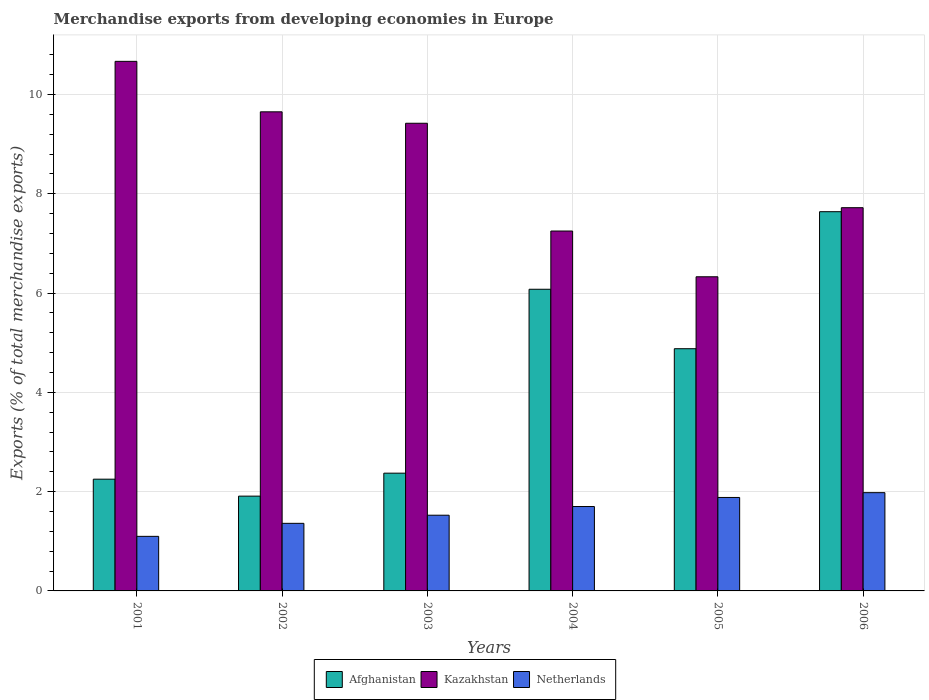How many different coloured bars are there?
Your response must be concise. 3. How many groups of bars are there?
Ensure brevity in your answer.  6. Are the number of bars per tick equal to the number of legend labels?
Provide a short and direct response. Yes. Are the number of bars on each tick of the X-axis equal?
Ensure brevity in your answer.  Yes. How many bars are there on the 1st tick from the left?
Give a very brief answer. 3. How many bars are there on the 3rd tick from the right?
Your answer should be very brief. 3. What is the label of the 2nd group of bars from the left?
Provide a succinct answer. 2002. What is the percentage of total merchandise exports in Kazakhstan in 2003?
Your response must be concise. 9.42. Across all years, what is the maximum percentage of total merchandise exports in Afghanistan?
Provide a succinct answer. 7.64. Across all years, what is the minimum percentage of total merchandise exports in Netherlands?
Offer a very short reply. 1.1. In which year was the percentage of total merchandise exports in Netherlands minimum?
Provide a succinct answer. 2001. What is the total percentage of total merchandise exports in Netherlands in the graph?
Your answer should be compact. 9.55. What is the difference between the percentage of total merchandise exports in Kazakhstan in 2004 and that in 2005?
Ensure brevity in your answer.  0.92. What is the difference between the percentage of total merchandise exports in Kazakhstan in 2001 and the percentage of total merchandise exports in Afghanistan in 2006?
Keep it short and to the point. 3.03. What is the average percentage of total merchandise exports in Netherlands per year?
Give a very brief answer. 1.59. In the year 2004, what is the difference between the percentage of total merchandise exports in Kazakhstan and percentage of total merchandise exports in Afghanistan?
Provide a succinct answer. 1.17. In how many years, is the percentage of total merchandise exports in Netherlands greater than 1.6 %?
Your answer should be very brief. 3. What is the ratio of the percentage of total merchandise exports in Netherlands in 2001 to that in 2006?
Provide a short and direct response. 0.56. What is the difference between the highest and the second highest percentage of total merchandise exports in Afghanistan?
Offer a very short reply. 1.56. What is the difference between the highest and the lowest percentage of total merchandise exports in Afghanistan?
Give a very brief answer. 5.73. Is the sum of the percentage of total merchandise exports in Kazakhstan in 2004 and 2006 greater than the maximum percentage of total merchandise exports in Afghanistan across all years?
Provide a succinct answer. Yes. What does the 2nd bar from the left in 2004 represents?
Give a very brief answer. Kazakhstan. What does the 2nd bar from the right in 2004 represents?
Ensure brevity in your answer.  Kazakhstan. Is it the case that in every year, the sum of the percentage of total merchandise exports in Kazakhstan and percentage of total merchandise exports in Netherlands is greater than the percentage of total merchandise exports in Afghanistan?
Your answer should be compact. Yes. Are all the bars in the graph horizontal?
Provide a short and direct response. No. How many years are there in the graph?
Ensure brevity in your answer.  6. Does the graph contain any zero values?
Ensure brevity in your answer.  No. Does the graph contain grids?
Offer a terse response. Yes. How many legend labels are there?
Offer a terse response. 3. How are the legend labels stacked?
Make the answer very short. Horizontal. What is the title of the graph?
Your answer should be compact. Merchandise exports from developing economies in Europe. What is the label or title of the Y-axis?
Give a very brief answer. Exports (% of total merchandise exports). What is the Exports (% of total merchandise exports) of Afghanistan in 2001?
Your answer should be compact. 2.25. What is the Exports (% of total merchandise exports) of Kazakhstan in 2001?
Ensure brevity in your answer.  10.67. What is the Exports (% of total merchandise exports) of Netherlands in 2001?
Offer a terse response. 1.1. What is the Exports (% of total merchandise exports) in Afghanistan in 2002?
Provide a short and direct response. 1.91. What is the Exports (% of total merchandise exports) in Kazakhstan in 2002?
Your answer should be compact. 9.65. What is the Exports (% of total merchandise exports) of Netherlands in 2002?
Your response must be concise. 1.36. What is the Exports (% of total merchandise exports) in Afghanistan in 2003?
Make the answer very short. 2.37. What is the Exports (% of total merchandise exports) in Kazakhstan in 2003?
Ensure brevity in your answer.  9.42. What is the Exports (% of total merchandise exports) in Netherlands in 2003?
Your response must be concise. 1.52. What is the Exports (% of total merchandise exports) of Afghanistan in 2004?
Ensure brevity in your answer.  6.08. What is the Exports (% of total merchandise exports) of Kazakhstan in 2004?
Your response must be concise. 7.25. What is the Exports (% of total merchandise exports) of Netherlands in 2004?
Your answer should be compact. 1.7. What is the Exports (% of total merchandise exports) of Afghanistan in 2005?
Provide a short and direct response. 4.88. What is the Exports (% of total merchandise exports) in Kazakhstan in 2005?
Make the answer very short. 6.33. What is the Exports (% of total merchandise exports) of Netherlands in 2005?
Make the answer very short. 1.88. What is the Exports (% of total merchandise exports) of Afghanistan in 2006?
Offer a terse response. 7.64. What is the Exports (% of total merchandise exports) in Kazakhstan in 2006?
Provide a succinct answer. 7.72. What is the Exports (% of total merchandise exports) in Netherlands in 2006?
Offer a very short reply. 1.98. Across all years, what is the maximum Exports (% of total merchandise exports) of Afghanistan?
Give a very brief answer. 7.64. Across all years, what is the maximum Exports (% of total merchandise exports) in Kazakhstan?
Ensure brevity in your answer.  10.67. Across all years, what is the maximum Exports (% of total merchandise exports) in Netherlands?
Your response must be concise. 1.98. Across all years, what is the minimum Exports (% of total merchandise exports) of Afghanistan?
Provide a succinct answer. 1.91. Across all years, what is the minimum Exports (% of total merchandise exports) in Kazakhstan?
Give a very brief answer. 6.33. Across all years, what is the minimum Exports (% of total merchandise exports) in Netherlands?
Ensure brevity in your answer.  1.1. What is the total Exports (% of total merchandise exports) in Afghanistan in the graph?
Ensure brevity in your answer.  25.12. What is the total Exports (% of total merchandise exports) in Kazakhstan in the graph?
Your answer should be very brief. 51.03. What is the total Exports (% of total merchandise exports) in Netherlands in the graph?
Provide a succinct answer. 9.55. What is the difference between the Exports (% of total merchandise exports) in Afghanistan in 2001 and that in 2002?
Keep it short and to the point. 0.34. What is the difference between the Exports (% of total merchandise exports) of Kazakhstan in 2001 and that in 2002?
Keep it short and to the point. 1.02. What is the difference between the Exports (% of total merchandise exports) of Netherlands in 2001 and that in 2002?
Make the answer very short. -0.26. What is the difference between the Exports (% of total merchandise exports) of Afghanistan in 2001 and that in 2003?
Offer a terse response. -0.12. What is the difference between the Exports (% of total merchandise exports) of Kazakhstan in 2001 and that in 2003?
Your answer should be compact. 1.25. What is the difference between the Exports (% of total merchandise exports) in Netherlands in 2001 and that in 2003?
Your response must be concise. -0.43. What is the difference between the Exports (% of total merchandise exports) in Afghanistan in 2001 and that in 2004?
Provide a succinct answer. -3.83. What is the difference between the Exports (% of total merchandise exports) of Kazakhstan in 2001 and that in 2004?
Your answer should be very brief. 3.42. What is the difference between the Exports (% of total merchandise exports) of Netherlands in 2001 and that in 2004?
Ensure brevity in your answer.  -0.6. What is the difference between the Exports (% of total merchandise exports) of Afghanistan in 2001 and that in 2005?
Give a very brief answer. -2.63. What is the difference between the Exports (% of total merchandise exports) in Kazakhstan in 2001 and that in 2005?
Provide a succinct answer. 4.34. What is the difference between the Exports (% of total merchandise exports) of Netherlands in 2001 and that in 2005?
Your answer should be very brief. -0.78. What is the difference between the Exports (% of total merchandise exports) in Afghanistan in 2001 and that in 2006?
Offer a terse response. -5.39. What is the difference between the Exports (% of total merchandise exports) of Kazakhstan in 2001 and that in 2006?
Give a very brief answer. 2.95. What is the difference between the Exports (% of total merchandise exports) in Netherlands in 2001 and that in 2006?
Make the answer very short. -0.88. What is the difference between the Exports (% of total merchandise exports) in Afghanistan in 2002 and that in 2003?
Provide a succinct answer. -0.46. What is the difference between the Exports (% of total merchandise exports) in Kazakhstan in 2002 and that in 2003?
Offer a terse response. 0.23. What is the difference between the Exports (% of total merchandise exports) in Netherlands in 2002 and that in 2003?
Offer a very short reply. -0.16. What is the difference between the Exports (% of total merchandise exports) in Afghanistan in 2002 and that in 2004?
Keep it short and to the point. -4.17. What is the difference between the Exports (% of total merchandise exports) of Kazakhstan in 2002 and that in 2004?
Your answer should be compact. 2.4. What is the difference between the Exports (% of total merchandise exports) in Netherlands in 2002 and that in 2004?
Make the answer very short. -0.34. What is the difference between the Exports (% of total merchandise exports) of Afghanistan in 2002 and that in 2005?
Provide a short and direct response. -2.97. What is the difference between the Exports (% of total merchandise exports) of Kazakhstan in 2002 and that in 2005?
Provide a short and direct response. 3.32. What is the difference between the Exports (% of total merchandise exports) in Netherlands in 2002 and that in 2005?
Provide a short and direct response. -0.52. What is the difference between the Exports (% of total merchandise exports) in Afghanistan in 2002 and that in 2006?
Provide a short and direct response. -5.73. What is the difference between the Exports (% of total merchandise exports) of Kazakhstan in 2002 and that in 2006?
Offer a very short reply. 1.93. What is the difference between the Exports (% of total merchandise exports) of Netherlands in 2002 and that in 2006?
Offer a very short reply. -0.62. What is the difference between the Exports (% of total merchandise exports) in Afghanistan in 2003 and that in 2004?
Your response must be concise. -3.7. What is the difference between the Exports (% of total merchandise exports) in Kazakhstan in 2003 and that in 2004?
Offer a terse response. 2.17. What is the difference between the Exports (% of total merchandise exports) in Netherlands in 2003 and that in 2004?
Provide a succinct answer. -0.18. What is the difference between the Exports (% of total merchandise exports) in Afghanistan in 2003 and that in 2005?
Your answer should be compact. -2.51. What is the difference between the Exports (% of total merchandise exports) in Kazakhstan in 2003 and that in 2005?
Ensure brevity in your answer.  3.09. What is the difference between the Exports (% of total merchandise exports) of Netherlands in 2003 and that in 2005?
Keep it short and to the point. -0.36. What is the difference between the Exports (% of total merchandise exports) in Afghanistan in 2003 and that in 2006?
Provide a succinct answer. -5.27. What is the difference between the Exports (% of total merchandise exports) of Kazakhstan in 2003 and that in 2006?
Offer a terse response. 1.7. What is the difference between the Exports (% of total merchandise exports) of Netherlands in 2003 and that in 2006?
Offer a very short reply. -0.45. What is the difference between the Exports (% of total merchandise exports) in Afghanistan in 2004 and that in 2005?
Make the answer very short. 1.2. What is the difference between the Exports (% of total merchandise exports) of Kazakhstan in 2004 and that in 2005?
Your answer should be very brief. 0.92. What is the difference between the Exports (% of total merchandise exports) of Netherlands in 2004 and that in 2005?
Provide a succinct answer. -0.18. What is the difference between the Exports (% of total merchandise exports) in Afghanistan in 2004 and that in 2006?
Provide a succinct answer. -1.56. What is the difference between the Exports (% of total merchandise exports) in Kazakhstan in 2004 and that in 2006?
Your answer should be very brief. -0.47. What is the difference between the Exports (% of total merchandise exports) of Netherlands in 2004 and that in 2006?
Ensure brevity in your answer.  -0.28. What is the difference between the Exports (% of total merchandise exports) of Afghanistan in 2005 and that in 2006?
Your response must be concise. -2.76. What is the difference between the Exports (% of total merchandise exports) of Kazakhstan in 2005 and that in 2006?
Your answer should be compact. -1.39. What is the difference between the Exports (% of total merchandise exports) of Netherlands in 2005 and that in 2006?
Offer a terse response. -0.1. What is the difference between the Exports (% of total merchandise exports) in Afghanistan in 2001 and the Exports (% of total merchandise exports) in Kazakhstan in 2002?
Make the answer very short. -7.4. What is the difference between the Exports (% of total merchandise exports) of Afghanistan in 2001 and the Exports (% of total merchandise exports) of Netherlands in 2002?
Provide a succinct answer. 0.89. What is the difference between the Exports (% of total merchandise exports) of Kazakhstan in 2001 and the Exports (% of total merchandise exports) of Netherlands in 2002?
Your answer should be very brief. 9.31. What is the difference between the Exports (% of total merchandise exports) in Afghanistan in 2001 and the Exports (% of total merchandise exports) in Kazakhstan in 2003?
Your answer should be compact. -7.17. What is the difference between the Exports (% of total merchandise exports) in Afghanistan in 2001 and the Exports (% of total merchandise exports) in Netherlands in 2003?
Give a very brief answer. 0.73. What is the difference between the Exports (% of total merchandise exports) of Kazakhstan in 2001 and the Exports (% of total merchandise exports) of Netherlands in 2003?
Your response must be concise. 9.14. What is the difference between the Exports (% of total merchandise exports) of Afghanistan in 2001 and the Exports (% of total merchandise exports) of Kazakhstan in 2004?
Your answer should be compact. -5. What is the difference between the Exports (% of total merchandise exports) in Afghanistan in 2001 and the Exports (% of total merchandise exports) in Netherlands in 2004?
Your response must be concise. 0.55. What is the difference between the Exports (% of total merchandise exports) of Kazakhstan in 2001 and the Exports (% of total merchandise exports) of Netherlands in 2004?
Provide a short and direct response. 8.97. What is the difference between the Exports (% of total merchandise exports) of Afghanistan in 2001 and the Exports (% of total merchandise exports) of Kazakhstan in 2005?
Offer a very short reply. -4.08. What is the difference between the Exports (% of total merchandise exports) of Afghanistan in 2001 and the Exports (% of total merchandise exports) of Netherlands in 2005?
Offer a very short reply. 0.37. What is the difference between the Exports (% of total merchandise exports) in Kazakhstan in 2001 and the Exports (% of total merchandise exports) in Netherlands in 2005?
Your answer should be compact. 8.78. What is the difference between the Exports (% of total merchandise exports) in Afghanistan in 2001 and the Exports (% of total merchandise exports) in Kazakhstan in 2006?
Your response must be concise. -5.47. What is the difference between the Exports (% of total merchandise exports) of Afghanistan in 2001 and the Exports (% of total merchandise exports) of Netherlands in 2006?
Ensure brevity in your answer.  0.27. What is the difference between the Exports (% of total merchandise exports) in Kazakhstan in 2001 and the Exports (% of total merchandise exports) in Netherlands in 2006?
Ensure brevity in your answer.  8.69. What is the difference between the Exports (% of total merchandise exports) of Afghanistan in 2002 and the Exports (% of total merchandise exports) of Kazakhstan in 2003?
Offer a very short reply. -7.51. What is the difference between the Exports (% of total merchandise exports) of Afghanistan in 2002 and the Exports (% of total merchandise exports) of Netherlands in 2003?
Ensure brevity in your answer.  0.38. What is the difference between the Exports (% of total merchandise exports) in Kazakhstan in 2002 and the Exports (% of total merchandise exports) in Netherlands in 2003?
Ensure brevity in your answer.  8.12. What is the difference between the Exports (% of total merchandise exports) in Afghanistan in 2002 and the Exports (% of total merchandise exports) in Kazakhstan in 2004?
Offer a terse response. -5.34. What is the difference between the Exports (% of total merchandise exports) of Afghanistan in 2002 and the Exports (% of total merchandise exports) of Netherlands in 2004?
Your response must be concise. 0.21. What is the difference between the Exports (% of total merchandise exports) in Kazakhstan in 2002 and the Exports (% of total merchandise exports) in Netherlands in 2004?
Your response must be concise. 7.95. What is the difference between the Exports (% of total merchandise exports) in Afghanistan in 2002 and the Exports (% of total merchandise exports) in Kazakhstan in 2005?
Your answer should be very brief. -4.42. What is the difference between the Exports (% of total merchandise exports) of Afghanistan in 2002 and the Exports (% of total merchandise exports) of Netherlands in 2005?
Your response must be concise. 0.03. What is the difference between the Exports (% of total merchandise exports) of Kazakhstan in 2002 and the Exports (% of total merchandise exports) of Netherlands in 2005?
Offer a very short reply. 7.77. What is the difference between the Exports (% of total merchandise exports) in Afghanistan in 2002 and the Exports (% of total merchandise exports) in Kazakhstan in 2006?
Your response must be concise. -5.81. What is the difference between the Exports (% of total merchandise exports) of Afghanistan in 2002 and the Exports (% of total merchandise exports) of Netherlands in 2006?
Keep it short and to the point. -0.07. What is the difference between the Exports (% of total merchandise exports) of Kazakhstan in 2002 and the Exports (% of total merchandise exports) of Netherlands in 2006?
Offer a very short reply. 7.67. What is the difference between the Exports (% of total merchandise exports) of Afghanistan in 2003 and the Exports (% of total merchandise exports) of Kazakhstan in 2004?
Provide a short and direct response. -4.88. What is the difference between the Exports (% of total merchandise exports) in Afghanistan in 2003 and the Exports (% of total merchandise exports) in Netherlands in 2004?
Your answer should be very brief. 0.67. What is the difference between the Exports (% of total merchandise exports) of Kazakhstan in 2003 and the Exports (% of total merchandise exports) of Netherlands in 2004?
Offer a very short reply. 7.72. What is the difference between the Exports (% of total merchandise exports) of Afghanistan in 2003 and the Exports (% of total merchandise exports) of Kazakhstan in 2005?
Your answer should be compact. -3.96. What is the difference between the Exports (% of total merchandise exports) of Afghanistan in 2003 and the Exports (% of total merchandise exports) of Netherlands in 2005?
Provide a succinct answer. 0.49. What is the difference between the Exports (% of total merchandise exports) in Kazakhstan in 2003 and the Exports (% of total merchandise exports) in Netherlands in 2005?
Your answer should be very brief. 7.54. What is the difference between the Exports (% of total merchandise exports) in Afghanistan in 2003 and the Exports (% of total merchandise exports) in Kazakhstan in 2006?
Keep it short and to the point. -5.35. What is the difference between the Exports (% of total merchandise exports) of Afghanistan in 2003 and the Exports (% of total merchandise exports) of Netherlands in 2006?
Your response must be concise. 0.39. What is the difference between the Exports (% of total merchandise exports) of Kazakhstan in 2003 and the Exports (% of total merchandise exports) of Netherlands in 2006?
Your answer should be compact. 7.44. What is the difference between the Exports (% of total merchandise exports) in Afghanistan in 2004 and the Exports (% of total merchandise exports) in Kazakhstan in 2005?
Ensure brevity in your answer.  -0.25. What is the difference between the Exports (% of total merchandise exports) of Afghanistan in 2004 and the Exports (% of total merchandise exports) of Netherlands in 2005?
Give a very brief answer. 4.19. What is the difference between the Exports (% of total merchandise exports) in Kazakhstan in 2004 and the Exports (% of total merchandise exports) in Netherlands in 2005?
Offer a terse response. 5.37. What is the difference between the Exports (% of total merchandise exports) of Afghanistan in 2004 and the Exports (% of total merchandise exports) of Kazakhstan in 2006?
Your answer should be very brief. -1.64. What is the difference between the Exports (% of total merchandise exports) of Afghanistan in 2004 and the Exports (% of total merchandise exports) of Netherlands in 2006?
Offer a very short reply. 4.1. What is the difference between the Exports (% of total merchandise exports) of Kazakhstan in 2004 and the Exports (% of total merchandise exports) of Netherlands in 2006?
Offer a very short reply. 5.27. What is the difference between the Exports (% of total merchandise exports) in Afghanistan in 2005 and the Exports (% of total merchandise exports) in Kazakhstan in 2006?
Provide a succinct answer. -2.84. What is the difference between the Exports (% of total merchandise exports) in Afghanistan in 2005 and the Exports (% of total merchandise exports) in Netherlands in 2006?
Ensure brevity in your answer.  2.9. What is the difference between the Exports (% of total merchandise exports) in Kazakhstan in 2005 and the Exports (% of total merchandise exports) in Netherlands in 2006?
Offer a terse response. 4.35. What is the average Exports (% of total merchandise exports) in Afghanistan per year?
Offer a very short reply. 4.19. What is the average Exports (% of total merchandise exports) of Kazakhstan per year?
Provide a succinct answer. 8.51. What is the average Exports (% of total merchandise exports) of Netherlands per year?
Provide a short and direct response. 1.59. In the year 2001, what is the difference between the Exports (% of total merchandise exports) of Afghanistan and Exports (% of total merchandise exports) of Kazakhstan?
Offer a terse response. -8.42. In the year 2001, what is the difference between the Exports (% of total merchandise exports) of Afghanistan and Exports (% of total merchandise exports) of Netherlands?
Give a very brief answer. 1.15. In the year 2001, what is the difference between the Exports (% of total merchandise exports) in Kazakhstan and Exports (% of total merchandise exports) in Netherlands?
Provide a short and direct response. 9.57. In the year 2002, what is the difference between the Exports (% of total merchandise exports) in Afghanistan and Exports (% of total merchandise exports) in Kazakhstan?
Give a very brief answer. -7.74. In the year 2002, what is the difference between the Exports (% of total merchandise exports) in Afghanistan and Exports (% of total merchandise exports) in Netherlands?
Your response must be concise. 0.55. In the year 2002, what is the difference between the Exports (% of total merchandise exports) of Kazakhstan and Exports (% of total merchandise exports) of Netherlands?
Offer a terse response. 8.29. In the year 2003, what is the difference between the Exports (% of total merchandise exports) in Afghanistan and Exports (% of total merchandise exports) in Kazakhstan?
Ensure brevity in your answer.  -7.05. In the year 2003, what is the difference between the Exports (% of total merchandise exports) of Afghanistan and Exports (% of total merchandise exports) of Netherlands?
Offer a very short reply. 0.85. In the year 2003, what is the difference between the Exports (% of total merchandise exports) of Kazakhstan and Exports (% of total merchandise exports) of Netherlands?
Offer a terse response. 7.89. In the year 2004, what is the difference between the Exports (% of total merchandise exports) in Afghanistan and Exports (% of total merchandise exports) in Kazakhstan?
Ensure brevity in your answer.  -1.17. In the year 2004, what is the difference between the Exports (% of total merchandise exports) of Afghanistan and Exports (% of total merchandise exports) of Netherlands?
Your answer should be compact. 4.38. In the year 2004, what is the difference between the Exports (% of total merchandise exports) in Kazakhstan and Exports (% of total merchandise exports) in Netherlands?
Give a very brief answer. 5.55. In the year 2005, what is the difference between the Exports (% of total merchandise exports) in Afghanistan and Exports (% of total merchandise exports) in Kazakhstan?
Your answer should be compact. -1.45. In the year 2005, what is the difference between the Exports (% of total merchandise exports) of Afghanistan and Exports (% of total merchandise exports) of Netherlands?
Your answer should be compact. 3. In the year 2005, what is the difference between the Exports (% of total merchandise exports) of Kazakhstan and Exports (% of total merchandise exports) of Netherlands?
Make the answer very short. 4.45. In the year 2006, what is the difference between the Exports (% of total merchandise exports) in Afghanistan and Exports (% of total merchandise exports) in Kazakhstan?
Keep it short and to the point. -0.08. In the year 2006, what is the difference between the Exports (% of total merchandise exports) in Afghanistan and Exports (% of total merchandise exports) in Netherlands?
Offer a terse response. 5.66. In the year 2006, what is the difference between the Exports (% of total merchandise exports) of Kazakhstan and Exports (% of total merchandise exports) of Netherlands?
Your response must be concise. 5.74. What is the ratio of the Exports (% of total merchandise exports) in Afghanistan in 2001 to that in 2002?
Your answer should be compact. 1.18. What is the ratio of the Exports (% of total merchandise exports) in Kazakhstan in 2001 to that in 2002?
Your response must be concise. 1.11. What is the ratio of the Exports (% of total merchandise exports) in Netherlands in 2001 to that in 2002?
Your answer should be compact. 0.81. What is the ratio of the Exports (% of total merchandise exports) in Afghanistan in 2001 to that in 2003?
Your answer should be very brief. 0.95. What is the ratio of the Exports (% of total merchandise exports) of Kazakhstan in 2001 to that in 2003?
Provide a succinct answer. 1.13. What is the ratio of the Exports (% of total merchandise exports) of Netherlands in 2001 to that in 2003?
Offer a terse response. 0.72. What is the ratio of the Exports (% of total merchandise exports) of Afghanistan in 2001 to that in 2004?
Give a very brief answer. 0.37. What is the ratio of the Exports (% of total merchandise exports) in Kazakhstan in 2001 to that in 2004?
Provide a short and direct response. 1.47. What is the ratio of the Exports (% of total merchandise exports) in Netherlands in 2001 to that in 2004?
Provide a succinct answer. 0.65. What is the ratio of the Exports (% of total merchandise exports) in Afghanistan in 2001 to that in 2005?
Your response must be concise. 0.46. What is the ratio of the Exports (% of total merchandise exports) of Kazakhstan in 2001 to that in 2005?
Offer a terse response. 1.69. What is the ratio of the Exports (% of total merchandise exports) of Netherlands in 2001 to that in 2005?
Your answer should be compact. 0.58. What is the ratio of the Exports (% of total merchandise exports) in Afghanistan in 2001 to that in 2006?
Offer a terse response. 0.29. What is the ratio of the Exports (% of total merchandise exports) in Kazakhstan in 2001 to that in 2006?
Give a very brief answer. 1.38. What is the ratio of the Exports (% of total merchandise exports) in Netherlands in 2001 to that in 2006?
Offer a very short reply. 0.56. What is the ratio of the Exports (% of total merchandise exports) in Afghanistan in 2002 to that in 2003?
Your answer should be compact. 0.81. What is the ratio of the Exports (% of total merchandise exports) in Kazakhstan in 2002 to that in 2003?
Your response must be concise. 1.02. What is the ratio of the Exports (% of total merchandise exports) of Netherlands in 2002 to that in 2003?
Offer a very short reply. 0.89. What is the ratio of the Exports (% of total merchandise exports) in Afghanistan in 2002 to that in 2004?
Make the answer very short. 0.31. What is the ratio of the Exports (% of total merchandise exports) in Kazakhstan in 2002 to that in 2004?
Make the answer very short. 1.33. What is the ratio of the Exports (% of total merchandise exports) in Netherlands in 2002 to that in 2004?
Your answer should be compact. 0.8. What is the ratio of the Exports (% of total merchandise exports) in Afghanistan in 2002 to that in 2005?
Make the answer very short. 0.39. What is the ratio of the Exports (% of total merchandise exports) of Kazakhstan in 2002 to that in 2005?
Your answer should be very brief. 1.52. What is the ratio of the Exports (% of total merchandise exports) in Netherlands in 2002 to that in 2005?
Your answer should be compact. 0.72. What is the ratio of the Exports (% of total merchandise exports) in Afghanistan in 2002 to that in 2006?
Provide a succinct answer. 0.25. What is the ratio of the Exports (% of total merchandise exports) in Kazakhstan in 2002 to that in 2006?
Give a very brief answer. 1.25. What is the ratio of the Exports (% of total merchandise exports) in Netherlands in 2002 to that in 2006?
Your answer should be very brief. 0.69. What is the ratio of the Exports (% of total merchandise exports) of Afghanistan in 2003 to that in 2004?
Your answer should be compact. 0.39. What is the ratio of the Exports (% of total merchandise exports) of Kazakhstan in 2003 to that in 2004?
Keep it short and to the point. 1.3. What is the ratio of the Exports (% of total merchandise exports) in Netherlands in 2003 to that in 2004?
Your response must be concise. 0.9. What is the ratio of the Exports (% of total merchandise exports) in Afghanistan in 2003 to that in 2005?
Your answer should be compact. 0.49. What is the ratio of the Exports (% of total merchandise exports) of Kazakhstan in 2003 to that in 2005?
Your answer should be compact. 1.49. What is the ratio of the Exports (% of total merchandise exports) of Netherlands in 2003 to that in 2005?
Your answer should be very brief. 0.81. What is the ratio of the Exports (% of total merchandise exports) of Afghanistan in 2003 to that in 2006?
Ensure brevity in your answer.  0.31. What is the ratio of the Exports (% of total merchandise exports) in Kazakhstan in 2003 to that in 2006?
Offer a terse response. 1.22. What is the ratio of the Exports (% of total merchandise exports) of Netherlands in 2003 to that in 2006?
Your answer should be compact. 0.77. What is the ratio of the Exports (% of total merchandise exports) of Afghanistan in 2004 to that in 2005?
Your answer should be compact. 1.25. What is the ratio of the Exports (% of total merchandise exports) of Kazakhstan in 2004 to that in 2005?
Offer a very short reply. 1.15. What is the ratio of the Exports (% of total merchandise exports) of Netherlands in 2004 to that in 2005?
Keep it short and to the point. 0.9. What is the ratio of the Exports (% of total merchandise exports) of Afghanistan in 2004 to that in 2006?
Ensure brevity in your answer.  0.8. What is the ratio of the Exports (% of total merchandise exports) of Kazakhstan in 2004 to that in 2006?
Your answer should be very brief. 0.94. What is the ratio of the Exports (% of total merchandise exports) of Netherlands in 2004 to that in 2006?
Provide a short and direct response. 0.86. What is the ratio of the Exports (% of total merchandise exports) in Afghanistan in 2005 to that in 2006?
Make the answer very short. 0.64. What is the ratio of the Exports (% of total merchandise exports) of Kazakhstan in 2005 to that in 2006?
Make the answer very short. 0.82. What is the ratio of the Exports (% of total merchandise exports) of Netherlands in 2005 to that in 2006?
Give a very brief answer. 0.95. What is the difference between the highest and the second highest Exports (% of total merchandise exports) of Afghanistan?
Ensure brevity in your answer.  1.56. What is the difference between the highest and the second highest Exports (% of total merchandise exports) in Kazakhstan?
Provide a short and direct response. 1.02. What is the difference between the highest and the second highest Exports (% of total merchandise exports) of Netherlands?
Keep it short and to the point. 0.1. What is the difference between the highest and the lowest Exports (% of total merchandise exports) of Afghanistan?
Make the answer very short. 5.73. What is the difference between the highest and the lowest Exports (% of total merchandise exports) of Kazakhstan?
Offer a terse response. 4.34. What is the difference between the highest and the lowest Exports (% of total merchandise exports) in Netherlands?
Your answer should be compact. 0.88. 